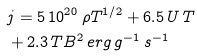<formula> <loc_0><loc_0><loc_500><loc_500>& j = 5 \, 1 0 ^ { 2 0 } \, \rho T ^ { 1 / 2 } + 6 . 5 \, U \, T \\ & + 2 . 3 \, T B ^ { 2 } \, e r g \, g ^ { - 1 } \, s ^ { - 1 }</formula> 